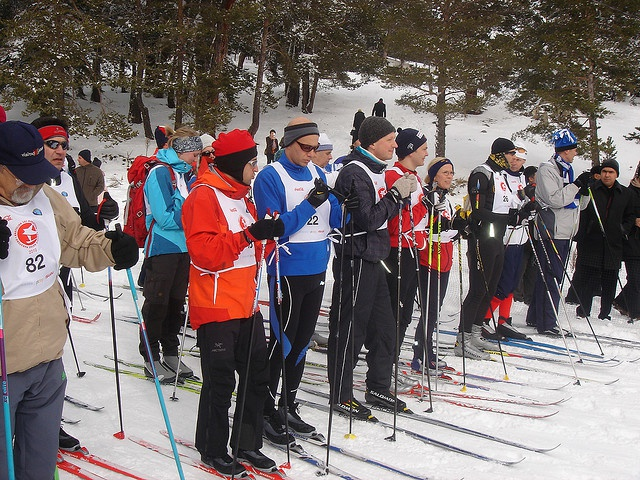Describe the objects in this image and their specific colors. I can see people in gray, black, lightgray, and darkgray tones, people in gray, black, and lavender tones, people in gray, black, red, and brown tones, people in gray, black, blue, lavender, and navy tones, and people in gray, black, darkgray, and lightgray tones in this image. 